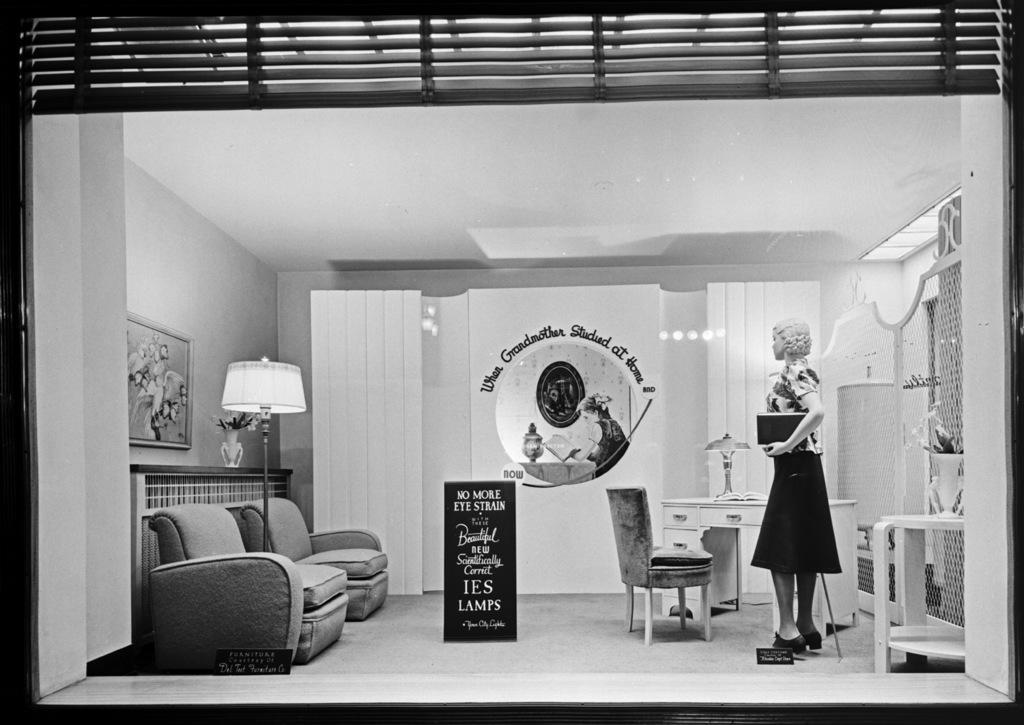In one or two sentences, can you explain what this image depicts? This black and white picture is taken from outside a room. There is glass and through it we can view the inside of the room. There is a couch, table, chair, lamp and flower vase. There is a mannequin in this picture and she is holding box in her hand. There is a table lamp on the table. Between the couch there is another lamp. On the wall there is picture frame hanging. In the center there is a board with text on it.  